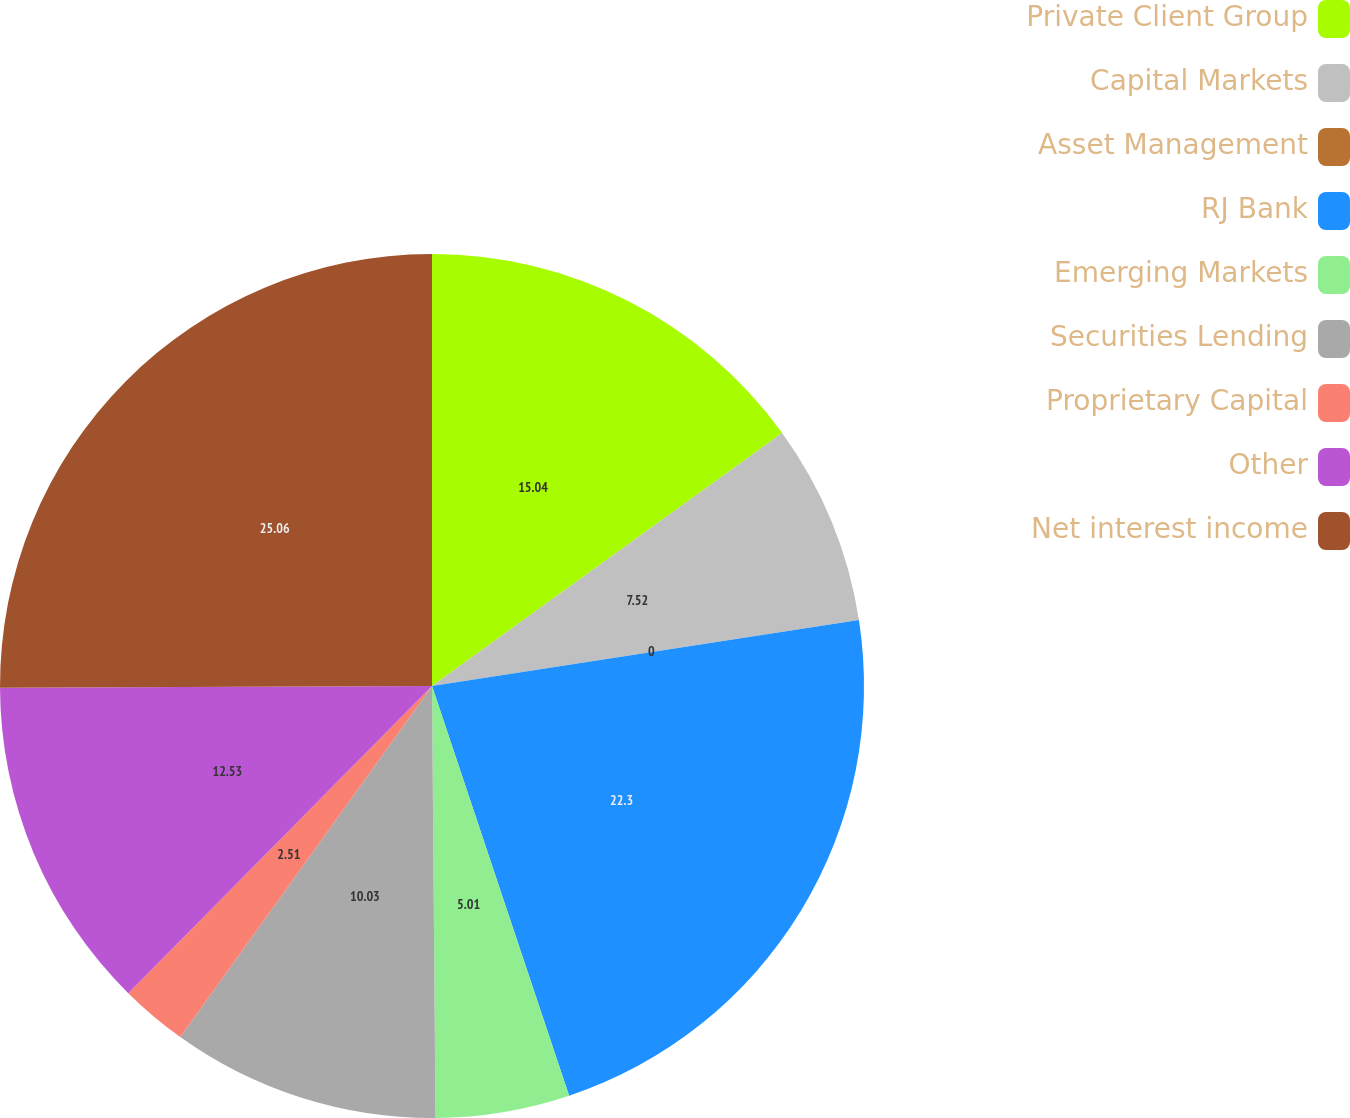Convert chart to OTSL. <chart><loc_0><loc_0><loc_500><loc_500><pie_chart><fcel>Private Client Group<fcel>Capital Markets<fcel>Asset Management<fcel>RJ Bank<fcel>Emerging Markets<fcel>Securities Lending<fcel>Proprietary Capital<fcel>Other<fcel>Net interest income<nl><fcel>15.04%<fcel>7.52%<fcel>0.0%<fcel>22.3%<fcel>5.01%<fcel>10.03%<fcel>2.51%<fcel>12.53%<fcel>25.06%<nl></chart> 